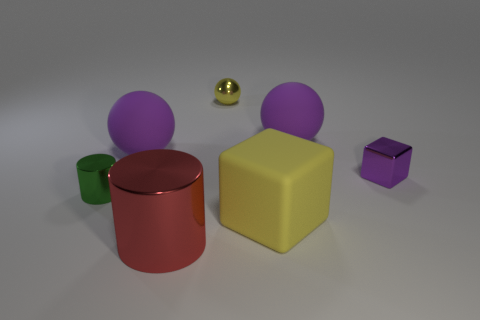Subtract all big spheres. How many spheres are left? 1 Add 2 purple matte objects. How many objects exist? 9 Subtract all yellow spheres. How many spheres are left? 2 Subtract all balls. How many objects are left? 4 Subtract all cyan spheres. How many green cylinders are left? 1 Add 1 green cylinders. How many green cylinders are left? 2 Add 4 yellow metal spheres. How many yellow metal spheres exist? 5 Subtract 0 blue cylinders. How many objects are left? 7 Subtract 2 balls. How many balls are left? 1 Subtract all gray balls. Subtract all yellow blocks. How many balls are left? 3 